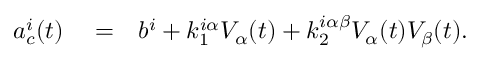<formula> <loc_0><loc_0><loc_500><loc_500>\begin{array} { r l r } { a _ { c } ^ { i } ( t ) } & = } & { b ^ { i } + k _ { 1 } ^ { i \alpha } V _ { \alpha } ( t ) + k _ { 2 } ^ { i \alpha \beta } V _ { \alpha } ( t ) V _ { \beta } ( t ) . } \end{array}</formula> 